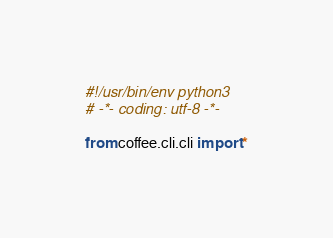<code> <loc_0><loc_0><loc_500><loc_500><_Python_>#!/usr/bin/env python3
# -*- coding: utf-8 -*-

from coffee.cli.cli import *
</code> 